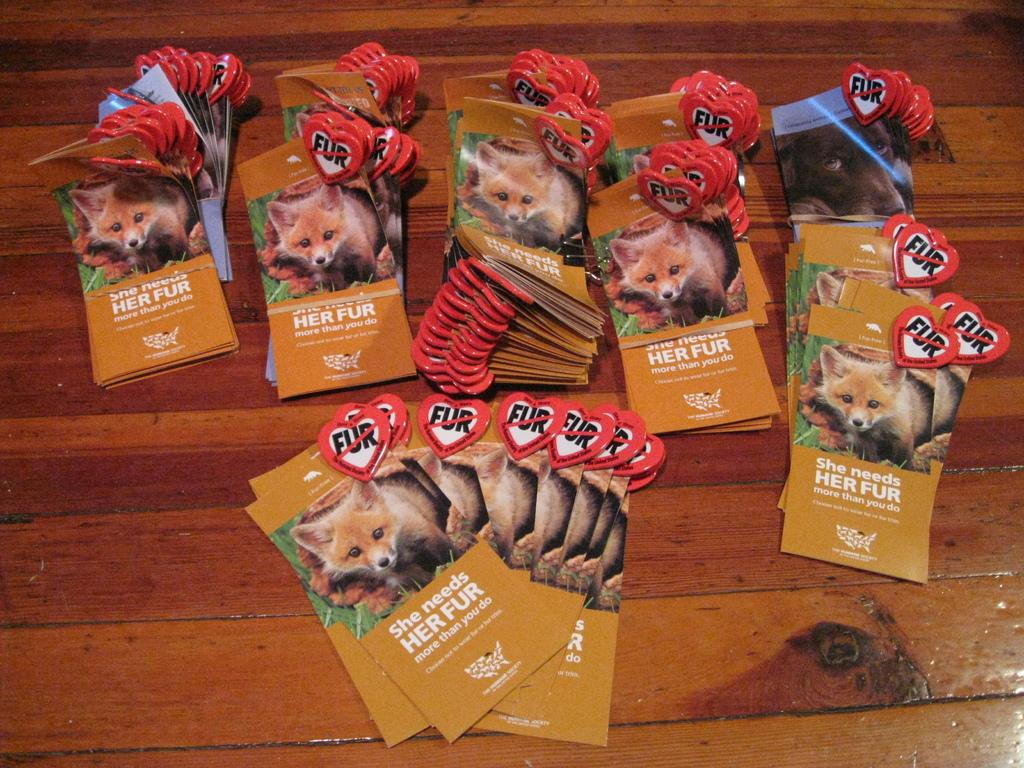What objects are present in the image? There are cards in the image. Can you describe the cards in more detail? The cards have an animal depicted on at least one of them, and there is text on the cards. What can be seen in the background of the image? There is a wooden object that looks like a table in the background of the image. Can you tell me how many keys are floating in the ocean in the image? There is no ocean or keys present in the image; it features cards with an animal and text, and a wooden object in the background. 